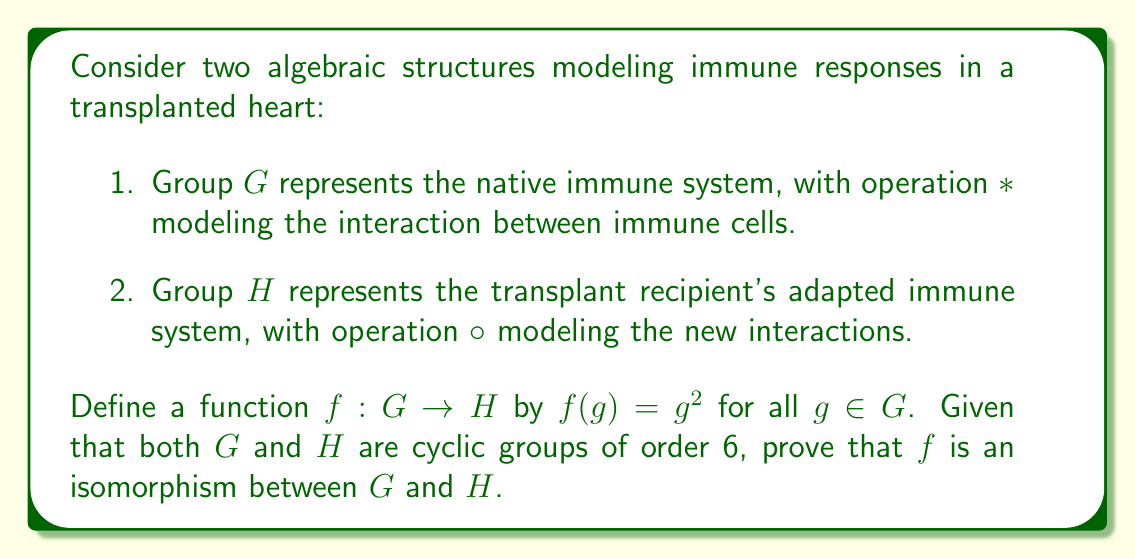Solve this math problem. To prove that $f$ is an isomorphism, we need to show that it is both injective (one-to-one) and surjective (onto), as well as structure-preserving (homomorphic).

1. Injectivity:
Let $a, b \in G$ such that $f(a) = f(b)$. This means $a^2 = b^2$.
Since $G$ is cyclic of order 6, we can write $a = g^i$ and $b = g^j$ for some generator $g$ and $i, j \in \{0, 1, 2, 3, 4, 5\}$.
Then, $(g^i)^2 = (g^j)^2 \implies g^{2i} = g^{2j} \implies 2i \equiv 2j \pmod{6}$.
This is equivalent to $i \equiv j \pmod{3}$, which, given the possible values of $i$ and $j$, implies $i = j$.
Therefore, $a = b$, proving injectivity.

2. Surjectivity:
For any $h \in H$, we need to find $g \in G$ such that $f(g) = h$.
Since $H$ is cyclic of order 6, we can write $h = h_0^k$ for some generator $h_0$ and $k \in \{0, 1, 2, 3, 4, 5\}$.
Let $g = g_0^m$, where $g_0$ is a generator of $G$ and $m$ is chosen such that $2m \equiv k \pmod{6}$.
Then $f(g) = (g_0^m)^2 = g_0^{2m} = h_0^k = h$.
Such an $m$ always exists (e.g., if $k$ is even, $m = k/2$; if $k$ is odd, $m = (k+3)/2$).
This proves surjectivity.

3. Homomorphism:
We need to show that $f(a * b) = f(a) \circ f(b)$ for all $a, b \in G$.
$f(a * b) = (a * b)^2 = a * b * a * b$
$f(a) \circ f(b) = a^2 \circ b^2 = a * a * b * b$
These are equal if and only if $b * a = a * b$, i.e., if $G$ is abelian.
Since $G$ is cyclic, it is abelian, so $f$ is indeed a homomorphism.

Since $f$ is injective, surjective, and homomorphic, it is an isomorphism between $G$ and $H$.
Answer: The function $f: G \rightarrow H$ defined by $f(g) = g^2$ is an isomorphism between the cyclic groups $G$ and $H$ of order 6, representing the native and adapted immune systems respectively. 